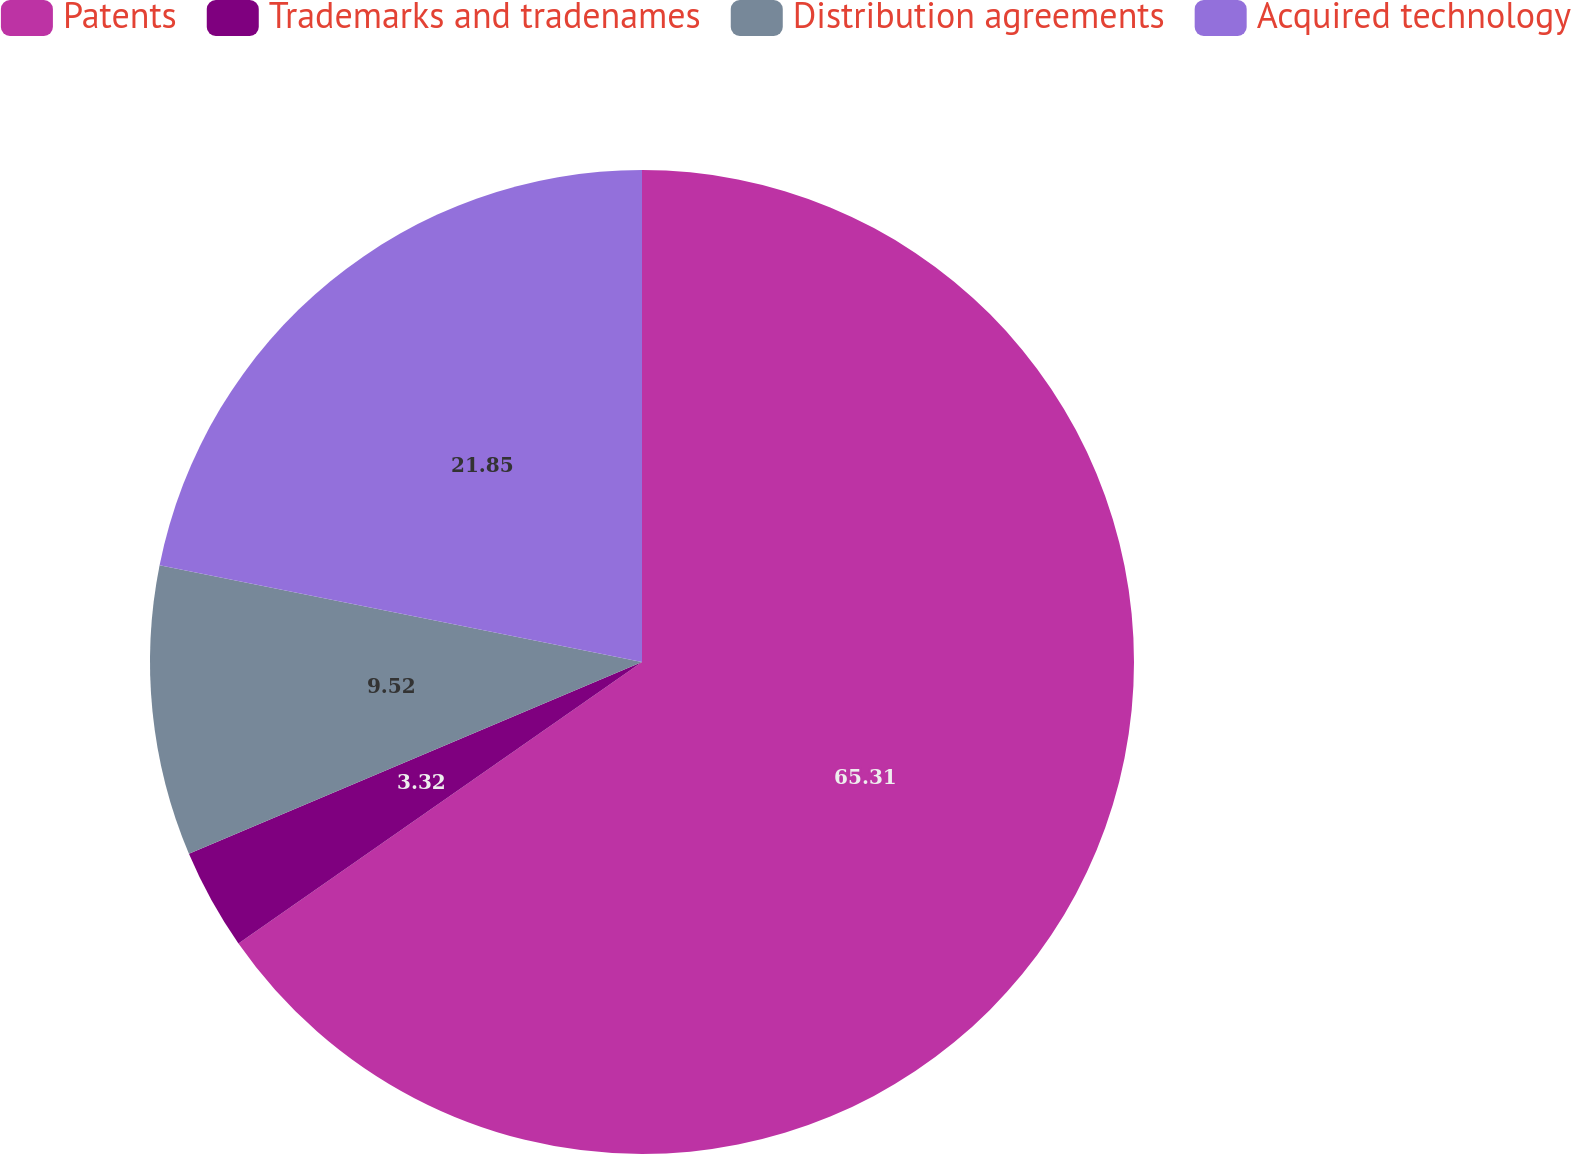Convert chart. <chart><loc_0><loc_0><loc_500><loc_500><pie_chart><fcel>Patents<fcel>Trademarks and tradenames<fcel>Distribution agreements<fcel>Acquired technology<nl><fcel>65.3%<fcel>3.32%<fcel>9.52%<fcel>21.85%<nl></chart> 